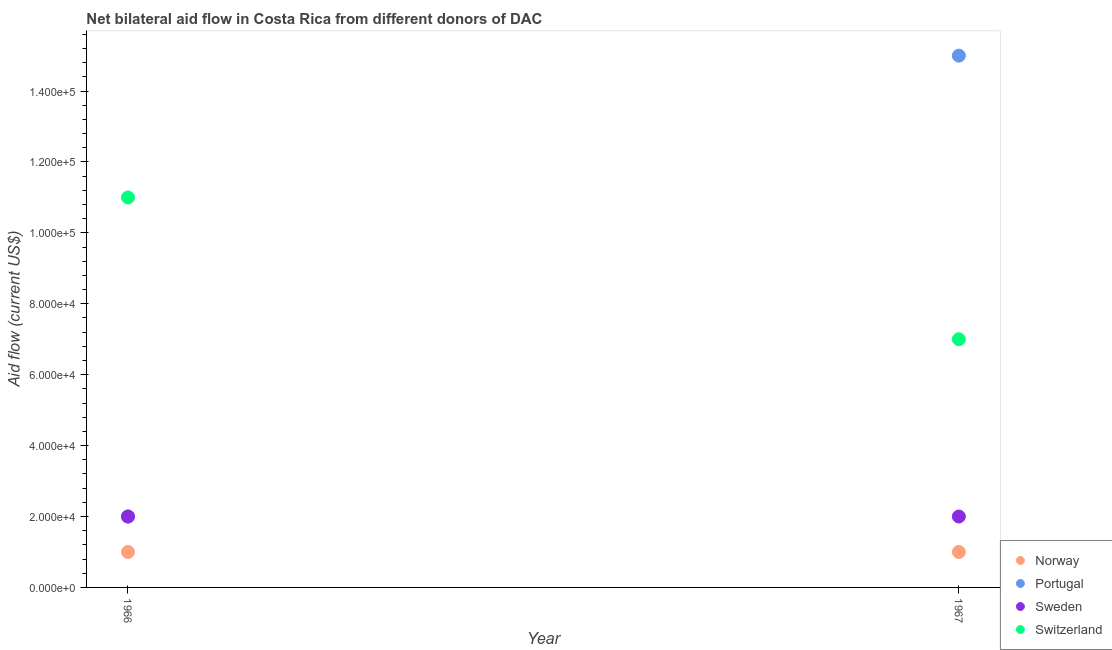How many different coloured dotlines are there?
Make the answer very short. 4. What is the amount of aid given by switzerland in 1967?
Offer a very short reply. 7.00e+04. Across all years, what is the maximum amount of aid given by portugal?
Offer a terse response. 1.50e+05. Across all years, what is the minimum amount of aid given by switzerland?
Ensure brevity in your answer.  7.00e+04. In which year was the amount of aid given by switzerland maximum?
Make the answer very short. 1966. In which year was the amount of aid given by norway minimum?
Offer a terse response. 1966. What is the total amount of aid given by sweden in the graph?
Your answer should be compact. 4.00e+04. What is the difference between the amount of aid given by sweden in 1966 and that in 1967?
Keep it short and to the point. 0. What is the difference between the amount of aid given by portugal in 1966 and the amount of aid given by switzerland in 1967?
Your response must be concise. -5.00e+04. In the year 1967, what is the difference between the amount of aid given by portugal and amount of aid given by switzerland?
Provide a succinct answer. 8.00e+04. In how many years, is the amount of aid given by switzerland greater than 16000 US$?
Offer a terse response. 2. What is the ratio of the amount of aid given by portugal in 1966 to that in 1967?
Ensure brevity in your answer.  0.13. Is the amount of aid given by sweden in 1966 less than that in 1967?
Make the answer very short. No. Is it the case that in every year, the sum of the amount of aid given by switzerland and amount of aid given by portugal is greater than the sum of amount of aid given by norway and amount of aid given by sweden?
Provide a short and direct response. No. Is it the case that in every year, the sum of the amount of aid given by norway and amount of aid given by portugal is greater than the amount of aid given by sweden?
Your response must be concise. Yes. Is the amount of aid given by switzerland strictly less than the amount of aid given by norway over the years?
Keep it short and to the point. No. How many dotlines are there?
Provide a short and direct response. 4. What is the difference between two consecutive major ticks on the Y-axis?
Your answer should be compact. 2.00e+04. Does the graph contain grids?
Your answer should be very brief. No. How many legend labels are there?
Offer a terse response. 4. How are the legend labels stacked?
Provide a short and direct response. Vertical. What is the title of the graph?
Ensure brevity in your answer.  Net bilateral aid flow in Costa Rica from different donors of DAC. What is the label or title of the X-axis?
Offer a very short reply. Year. What is the Aid flow (current US$) of Sweden in 1966?
Provide a short and direct response. 2.00e+04. What is the Aid flow (current US$) in Norway in 1967?
Your answer should be compact. 10000. Across all years, what is the minimum Aid flow (current US$) of Portugal?
Keep it short and to the point. 2.00e+04. What is the total Aid flow (current US$) in Sweden in the graph?
Offer a terse response. 4.00e+04. What is the difference between the Aid flow (current US$) in Sweden in 1966 and that in 1967?
Provide a short and direct response. 0. What is the average Aid flow (current US$) in Norway per year?
Your answer should be very brief. 10000. What is the average Aid flow (current US$) of Portugal per year?
Your response must be concise. 8.50e+04. What is the average Aid flow (current US$) of Sweden per year?
Offer a terse response. 2.00e+04. What is the average Aid flow (current US$) of Switzerland per year?
Provide a short and direct response. 9.00e+04. In the year 1966, what is the difference between the Aid flow (current US$) in Norway and Aid flow (current US$) in Portugal?
Your answer should be very brief. -10000. In the year 1966, what is the difference between the Aid flow (current US$) of Norway and Aid flow (current US$) of Sweden?
Offer a very short reply. -10000. In the year 1966, what is the difference between the Aid flow (current US$) of Norway and Aid flow (current US$) of Switzerland?
Offer a very short reply. -1.00e+05. In the year 1966, what is the difference between the Aid flow (current US$) of Portugal and Aid flow (current US$) of Sweden?
Ensure brevity in your answer.  0. In the year 1967, what is the difference between the Aid flow (current US$) of Norway and Aid flow (current US$) of Sweden?
Offer a very short reply. -10000. In the year 1967, what is the difference between the Aid flow (current US$) of Sweden and Aid flow (current US$) of Switzerland?
Provide a succinct answer. -5.00e+04. What is the ratio of the Aid flow (current US$) of Norway in 1966 to that in 1967?
Your answer should be compact. 1. What is the ratio of the Aid flow (current US$) of Portugal in 1966 to that in 1967?
Make the answer very short. 0.13. What is the ratio of the Aid flow (current US$) of Switzerland in 1966 to that in 1967?
Provide a short and direct response. 1.57. What is the difference between the highest and the second highest Aid flow (current US$) in Portugal?
Keep it short and to the point. 1.30e+05. What is the difference between the highest and the lowest Aid flow (current US$) of Sweden?
Keep it short and to the point. 0. What is the difference between the highest and the lowest Aid flow (current US$) of Switzerland?
Your answer should be compact. 4.00e+04. 